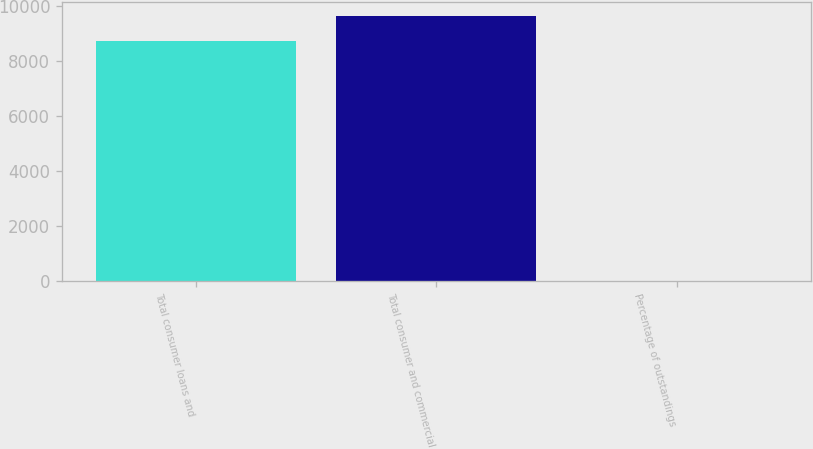<chart> <loc_0><loc_0><loc_500><loc_500><bar_chart><fcel>Total consumer loans and<fcel>Total consumer and commercial<fcel>Percentage of outstandings<nl><fcel>8727<fcel>9656.8<fcel>1.02<nl></chart> 